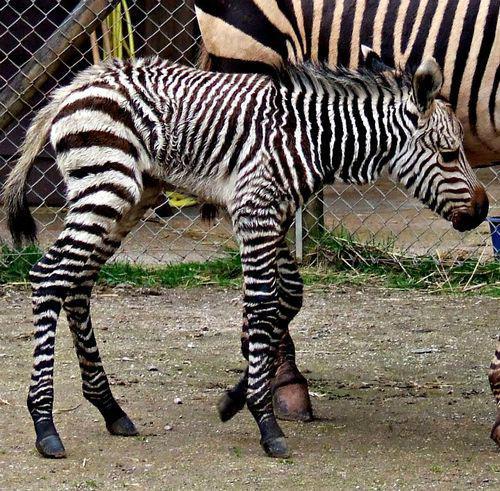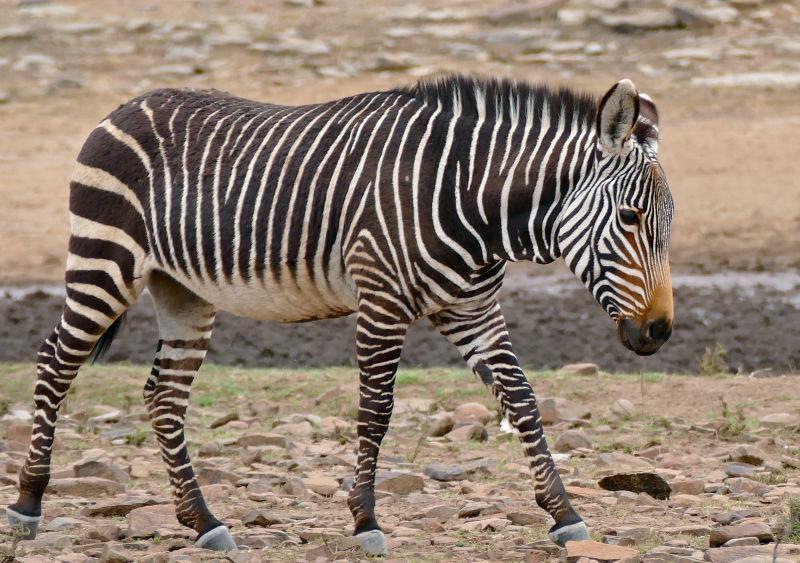The first image is the image on the left, the second image is the image on the right. Assess this claim about the two images: "There is a single zebra in at least one of the images.". Correct or not? Answer yes or no. Yes. 